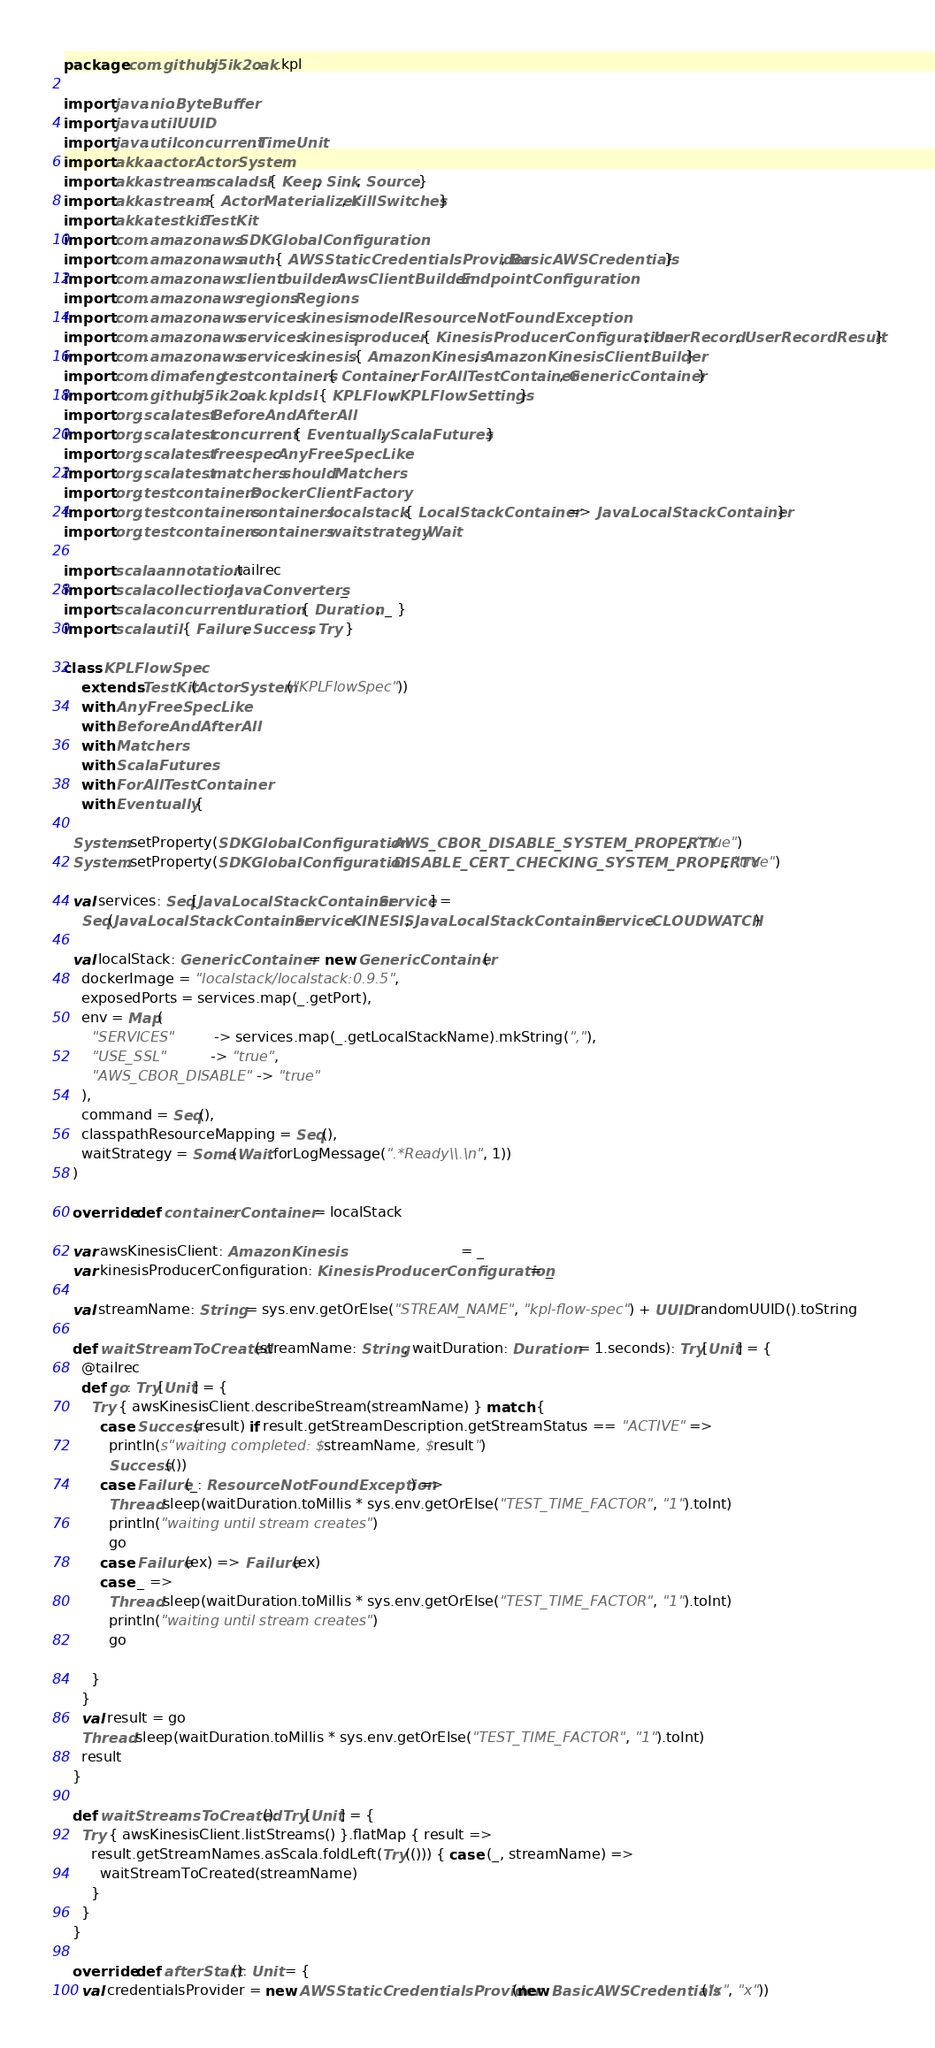Convert code to text. <code><loc_0><loc_0><loc_500><loc_500><_Scala_>package com.github.j5ik2o.ak.kpl

import java.nio.ByteBuffer
import java.util.UUID
import java.util.concurrent.TimeUnit
import akka.actor.ActorSystem
import akka.stream.scaladsl.{ Keep, Sink, Source }
import akka.stream.{ ActorMaterializer, KillSwitches }
import akka.testkit.TestKit
import com.amazonaws.SDKGlobalConfiguration
import com.amazonaws.auth.{ AWSStaticCredentialsProvider, BasicAWSCredentials }
import com.amazonaws.client.builder.AwsClientBuilder.EndpointConfiguration
import com.amazonaws.regions.Regions
import com.amazonaws.services.kinesis.model.ResourceNotFoundException
import com.amazonaws.services.kinesis.producer.{ KinesisProducerConfiguration, UserRecord, UserRecordResult }
import com.amazonaws.services.kinesis.{ AmazonKinesis, AmazonKinesisClientBuilder }
import com.dimafeng.testcontainers.{ Container, ForAllTestContainer, GenericContainer }
import com.github.j5ik2o.ak.kpl.dsl.{ KPLFlow, KPLFlowSettings }
import org.scalatest.BeforeAndAfterAll
import org.scalatest.concurrent.{ Eventually, ScalaFutures }
import org.scalatest.freespec.AnyFreeSpecLike
import org.scalatest.matchers.should.Matchers
import org.testcontainers.DockerClientFactory
import org.testcontainers.containers.localstack.{ LocalStackContainer => JavaLocalStackContainer }
import org.testcontainers.containers.wait.strategy.Wait

import scala.annotation.tailrec
import scala.collection.JavaConverters._
import scala.concurrent.duration.{ Duration, _ }
import scala.util.{ Failure, Success, Try }

class KPLFlowSpec
    extends TestKit(ActorSystem("KPLFlowSpec"))
    with AnyFreeSpecLike
    with BeforeAndAfterAll
    with Matchers
    with ScalaFutures
    with ForAllTestContainer
    with Eventually {

  System.setProperty(SDKGlobalConfiguration.AWS_CBOR_DISABLE_SYSTEM_PROPERTY, "true")
  System.setProperty(SDKGlobalConfiguration.DISABLE_CERT_CHECKING_SYSTEM_PROPERTY, "true")

  val services: Seq[JavaLocalStackContainer.Service] =
    Seq(JavaLocalStackContainer.Service.KINESIS, JavaLocalStackContainer.Service.CLOUDWATCH)

  val localStack: GenericContainer = new GenericContainer(
    dockerImage = "localstack/localstack:0.9.5",
    exposedPorts = services.map(_.getPort),
    env = Map(
      "SERVICES"         -> services.map(_.getLocalStackName).mkString(","),
      "USE_SSL"          -> "true",
      "AWS_CBOR_DISABLE" -> "true"
    ),
    command = Seq(),
    classpathResourceMapping = Seq(),
    waitStrategy = Some(Wait.forLogMessage(".*Ready\\.\n", 1))
  )

  override def container: Container = localStack

  var awsKinesisClient: AmazonKinesis                            = _
  var kinesisProducerConfiguration: KinesisProducerConfiguration = _

  val streamName: String = sys.env.getOrElse("STREAM_NAME", "kpl-flow-spec") + UUID.randomUUID().toString

  def waitStreamToCreated(streamName: String, waitDuration: Duration = 1.seconds): Try[Unit] = {
    @tailrec
    def go: Try[Unit] = {
      Try { awsKinesisClient.describeStream(streamName) } match {
        case Success(result) if result.getStreamDescription.getStreamStatus == "ACTIVE" =>
          println(s"waiting completed: $streamName, $result")
          Success(())
        case Failure(_: ResourceNotFoundException) =>
          Thread.sleep(waitDuration.toMillis * sys.env.getOrElse("TEST_TIME_FACTOR", "1").toInt)
          println("waiting until stream creates")
          go
        case Failure(ex) => Failure(ex)
        case _ =>
          Thread.sleep(waitDuration.toMillis * sys.env.getOrElse("TEST_TIME_FACTOR", "1").toInt)
          println("waiting until stream creates")
          go

      }
    }
    val result = go
    Thread.sleep(waitDuration.toMillis * sys.env.getOrElse("TEST_TIME_FACTOR", "1").toInt)
    result
  }

  def waitStreamsToCreated(): Try[Unit] = {
    Try { awsKinesisClient.listStreams() }.flatMap { result =>
      result.getStreamNames.asScala.foldLeft(Try(())) { case (_, streamName) =>
        waitStreamToCreated(streamName)
      }
    }
  }

  override def afterStart(): Unit = {
    val credentialsProvider = new AWSStaticCredentialsProvider(new BasicAWSCredentials("x", "x"))</code> 